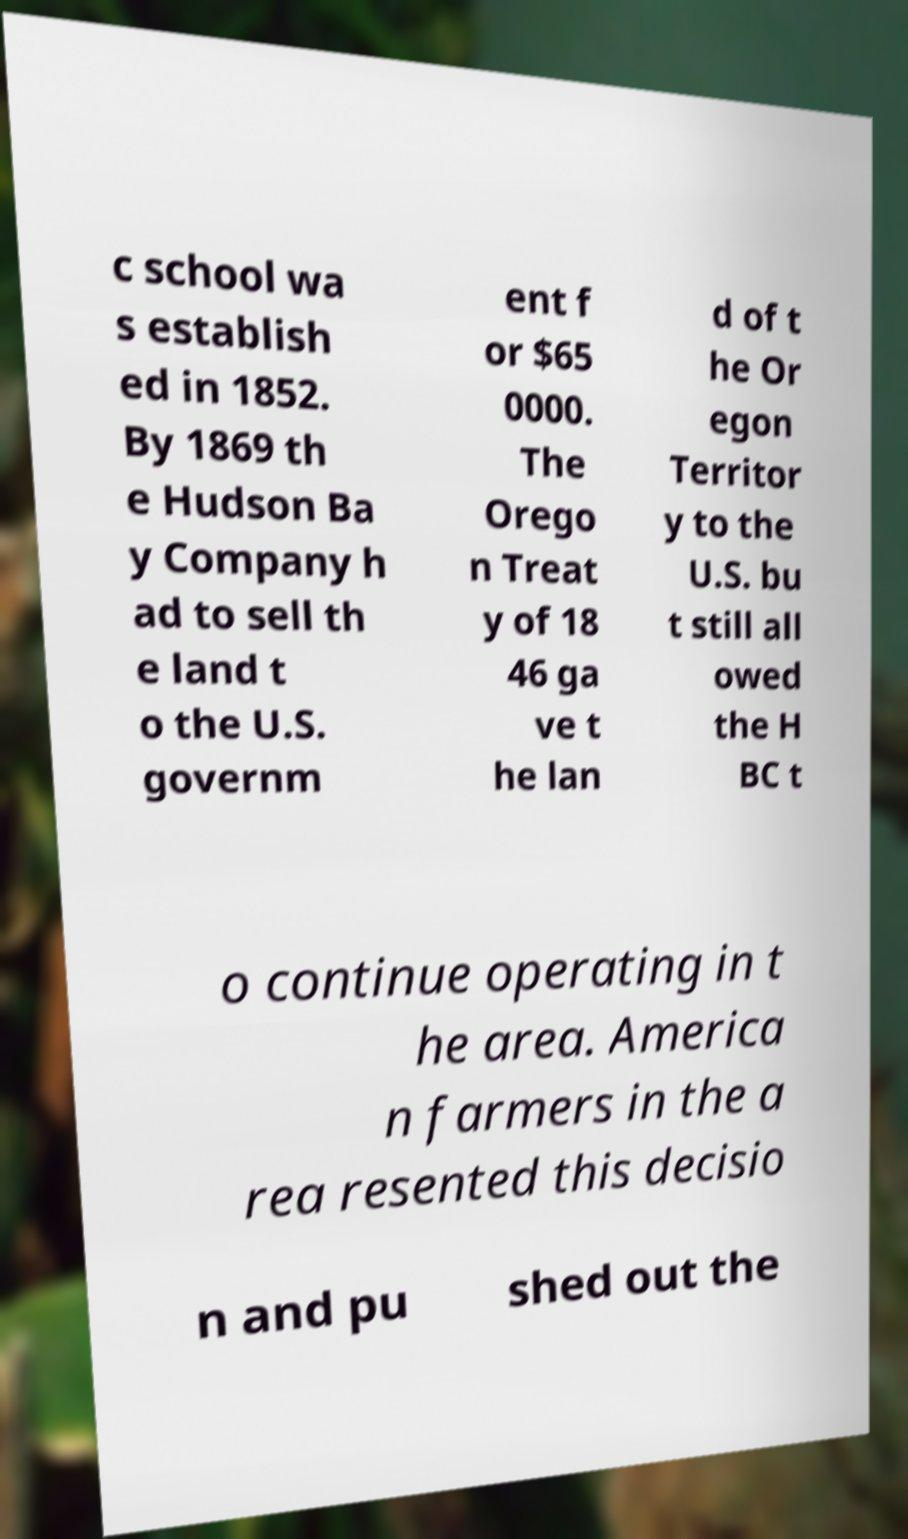I need the written content from this picture converted into text. Can you do that? c school wa s establish ed in 1852. By 1869 th e Hudson Ba y Company h ad to sell th e land t o the U.S. governm ent f or $65 0000. The Orego n Treat y of 18 46 ga ve t he lan d of t he Or egon Territor y to the U.S. bu t still all owed the H BC t o continue operating in t he area. America n farmers in the a rea resented this decisio n and pu shed out the 